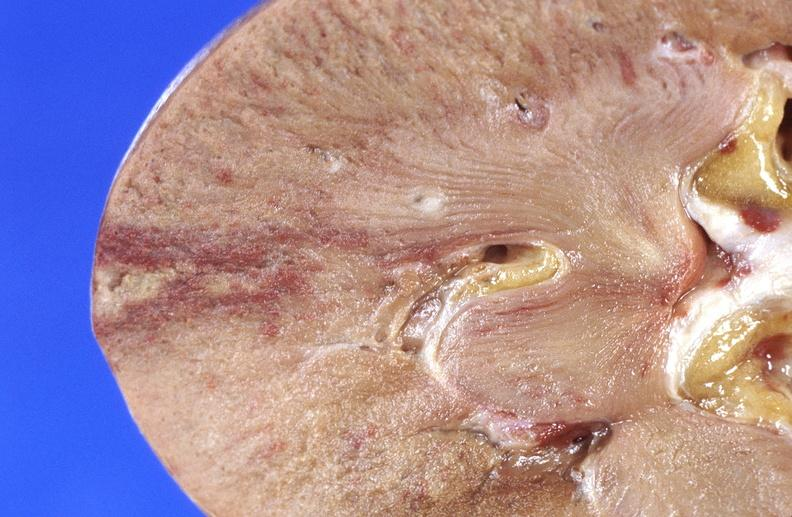where is this?
Answer the question using a single word or phrase. Urinary 